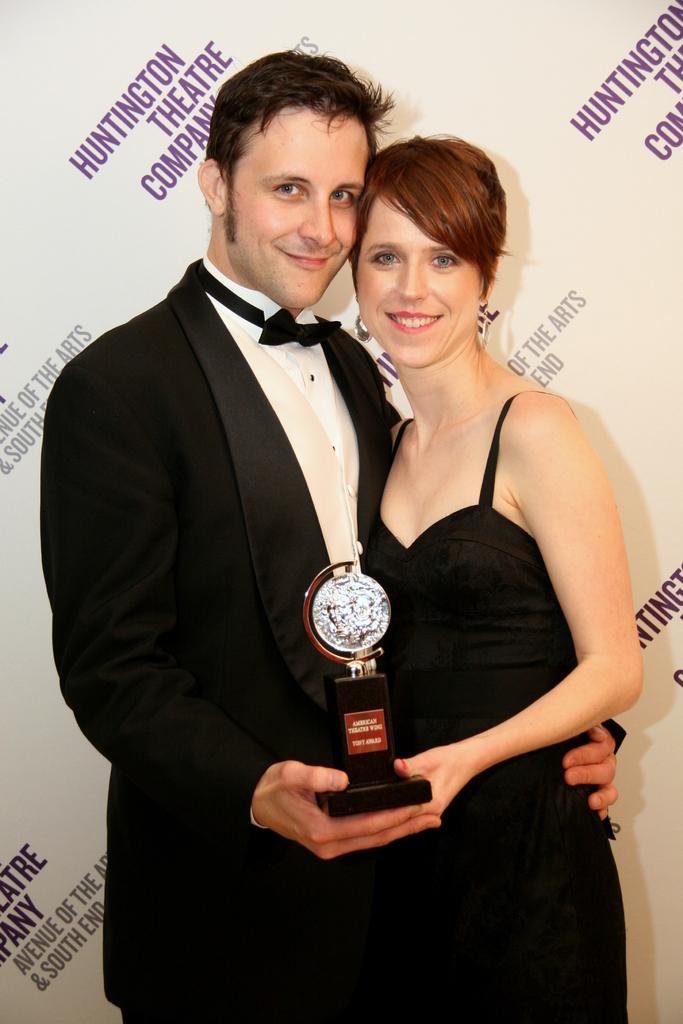What is the name of the company?
Give a very brief answer. Huntington theatre company. 